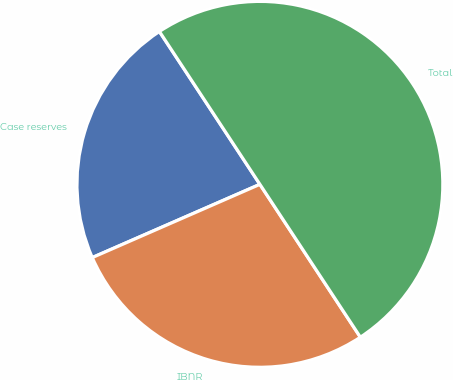Convert chart to OTSL. <chart><loc_0><loc_0><loc_500><loc_500><pie_chart><fcel>Case reserves<fcel>IBNR<fcel>Total<nl><fcel>22.3%<fcel>27.7%<fcel>50.0%<nl></chart> 